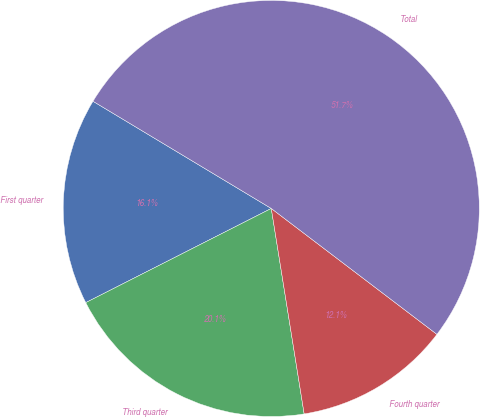Convert chart. <chart><loc_0><loc_0><loc_500><loc_500><pie_chart><fcel>First quarter<fcel>Third quarter<fcel>Fourth quarter<fcel>Total<nl><fcel>16.09%<fcel>20.05%<fcel>12.13%<fcel>51.72%<nl></chart> 